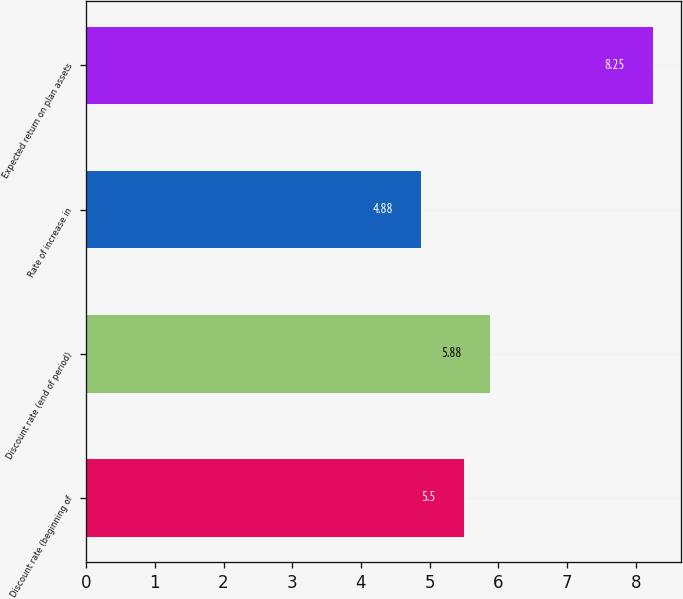Convert chart. <chart><loc_0><loc_0><loc_500><loc_500><bar_chart><fcel>Discount rate (beginning of<fcel>Discount rate (end of period)<fcel>Rate of increase in<fcel>Expected return on plan assets<nl><fcel>5.5<fcel>5.88<fcel>4.88<fcel>8.25<nl></chart> 